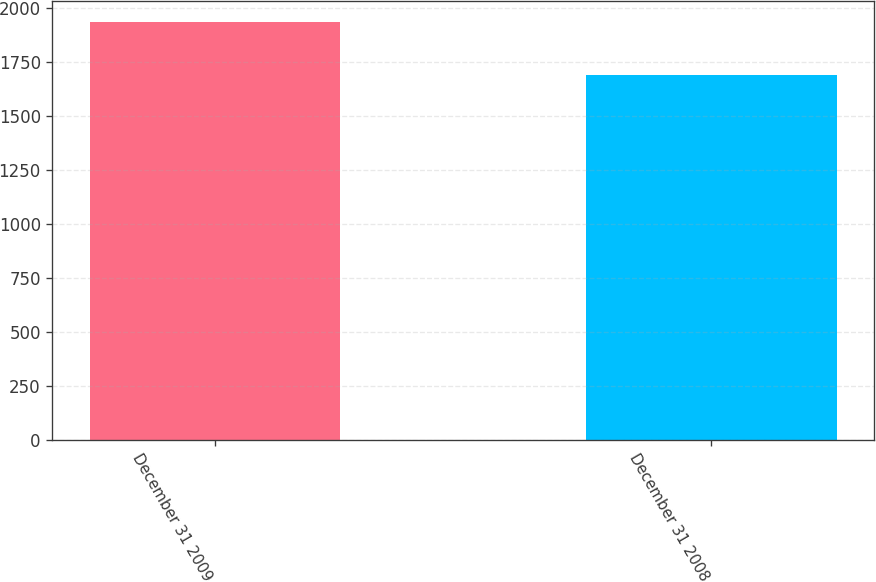<chart> <loc_0><loc_0><loc_500><loc_500><bar_chart><fcel>December 31 2009<fcel>December 31 2008<nl><fcel>1933<fcel>1690<nl></chart> 